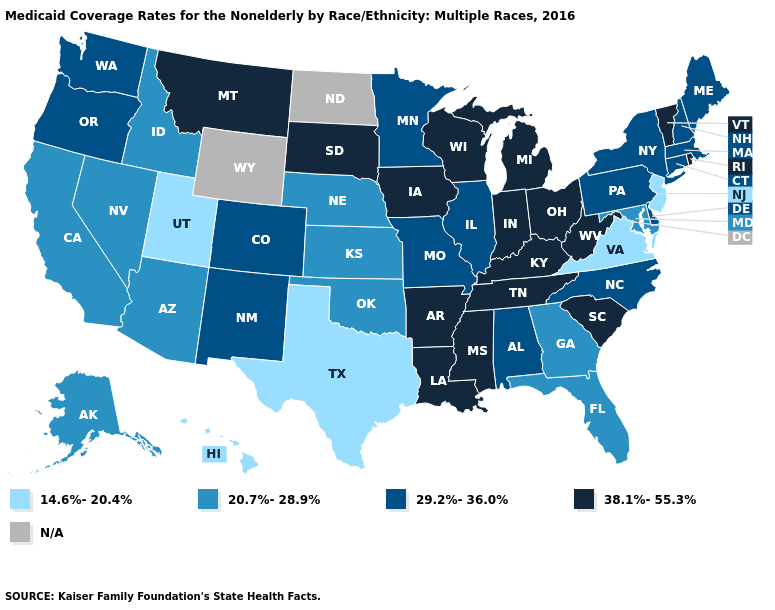Name the states that have a value in the range 29.2%-36.0%?
Short answer required. Alabama, Colorado, Connecticut, Delaware, Illinois, Maine, Massachusetts, Minnesota, Missouri, New Hampshire, New Mexico, New York, North Carolina, Oregon, Pennsylvania, Washington. What is the highest value in states that border Alabama?
Answer briefly. 38.1%-55.3%. Name the states that have a value in the range 38.1%-55.3%?
Keep it brief. Arkansas, Indiana, Iowa, Kentucky, Louisiana, Michigan, Mississippi, Montana, Ohio, Rhode Island, South Carolina, South Dakota, Tennessee, Vermont, West Virginia, Wisconsin. What is the value of Iowa?
Keep it brief. 38.1%-55.3%. Does Florida have the lowest value in the USA?
Write a very short answer. No. Name the states that have a value in the range 20.7%-28.9%?
Answer briefly. Alaska, Arizona, California, Florida, Georgia, Idaho, Kansas, Maryland, Nebraska, Nevada, Oklahoma. Which states have the lowest value in the South?
Give a very brief answer. Texas, Virginia. What is the value of North Dakota?
Give a very brief answer. N/A. Which states have the highest value in the USA?
Write a very short answer. Arkansas, Indiana, Iowa, Kentucky, Louisiana, Michigan, Mississippi, Montana, Ohio, Rhode Island, South Carolina, South Dakota, Tennessee, Vermont, West Virginia, Wisconsin. Which states hav the highest value in the West?
Short answer required. Montana. Does Montana have the highest value in the USA?
Answer briefly. Yes. How many symbols are there in the legend?
Be succinct. 5. Name the states that have a value in the range 29.2%-36.0%?
Give a very brief answer. Alabama, Colorado, Connecticut, Delaware, Illinois, Maine, Massachusetts, Minnesota, Missouri, New Hampshire, New Mexico, New York, North Carolina, Oregon, Pennsylvania, Washington. What is the highest value in the Northeast ?
Give a very brief answer. 38.1%-55.3%. 